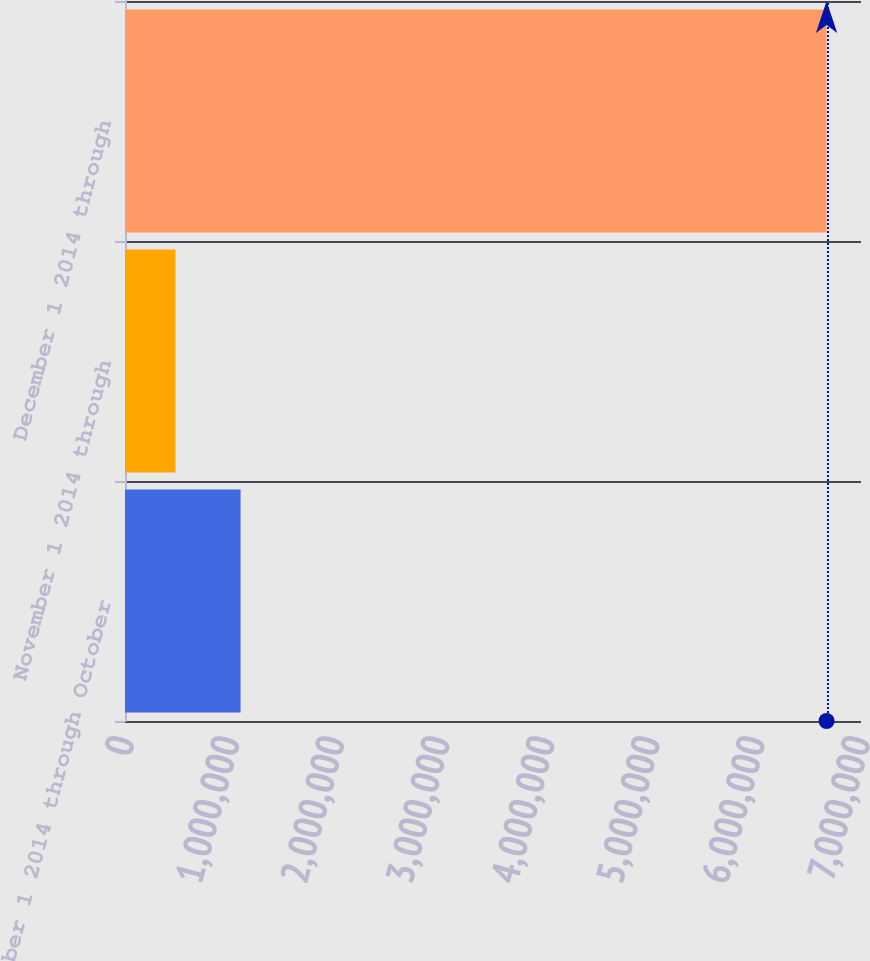Convert chart. <chart><loc_0><loc_0><loc_500><loc_500><bar_chart><fcel>October 1 2014 through October<fcel>November 1 2014 through<fcel>December 1 2014 through<nl><fcel>1.09909e+06<fcel>479830<fcel>6.67247e+06<nl></chart> 